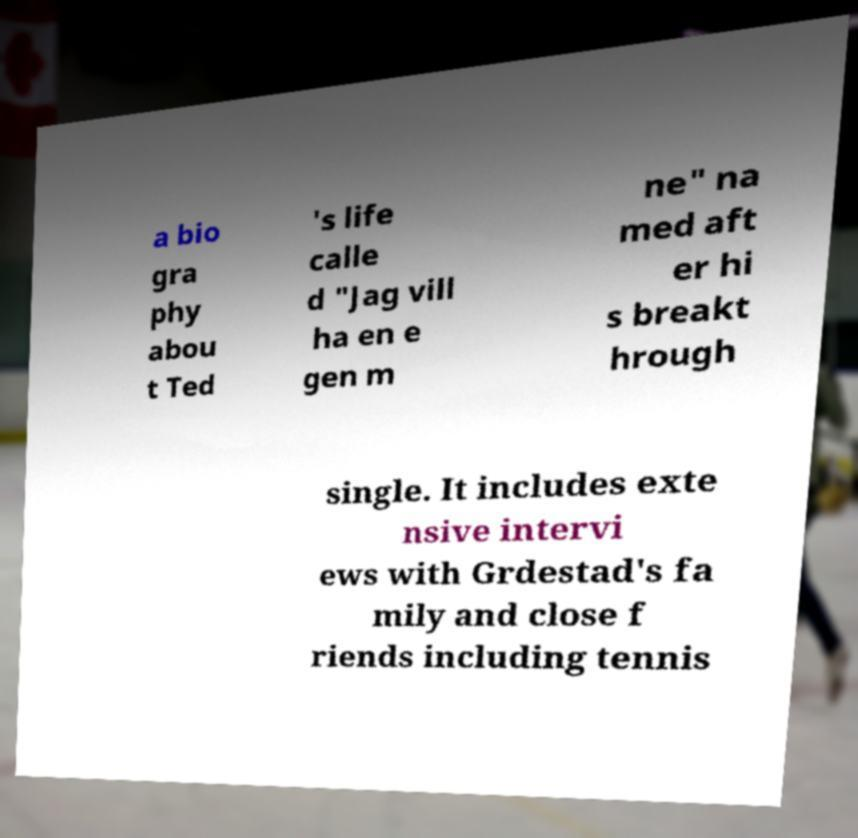Please read and relay the text visible in this image. What does it say? a bio gra phy abou t Ted 's life calle d "Jag vill ha en e gen m ne" na med aft er hi s breakt hrough single. It includes exte nsive intervi ews with Grdestad's fa mily and close f riends including tennis 